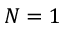Convert formula to latex. <formula><loc_0><loc_0><loc_500><loc_500>N = 1</formula> 